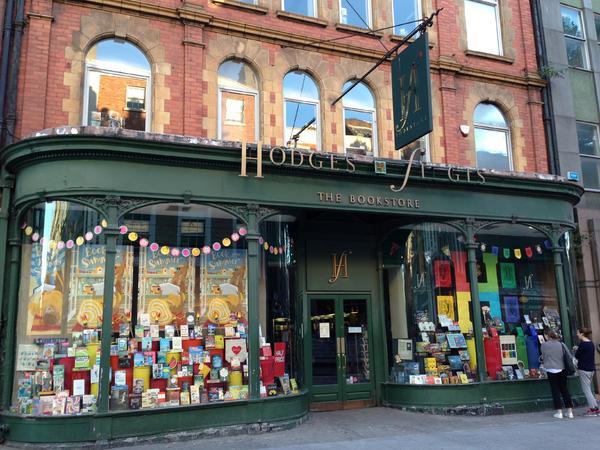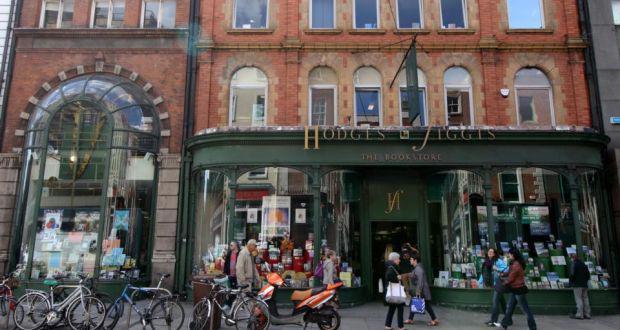The first image is the image on the left, the second image is the image on the right. For the images displayed, is the sentence "Left and right images show the same store exterior, and each storefront has a row of windows with tops that are at least slightly arched." factually correct? Answer yes or no. Yes. The first image is the image on the left, the second image is the image on the right. Examine the images to the left and right. Is the description "People are walking past the shop in the image on the right." accurate? Answer yes or no. Yes. 